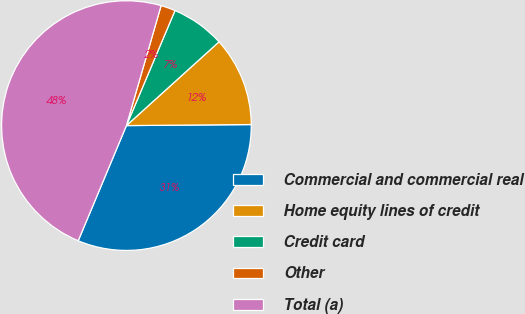Convert chart. <chart><loc_0><loc_0><loc_500><loc_500><pie_chart><fcel>Commercial and commercial real<fcel>Home equity lines of credit<fcel>Credit card<fcel>Other<fcel>Total (a)<nl><fcel>31.44%<fcel>11.57%<fcel>6.94%<fcel>1.88%<fcel>48.17%<nl></chart> 